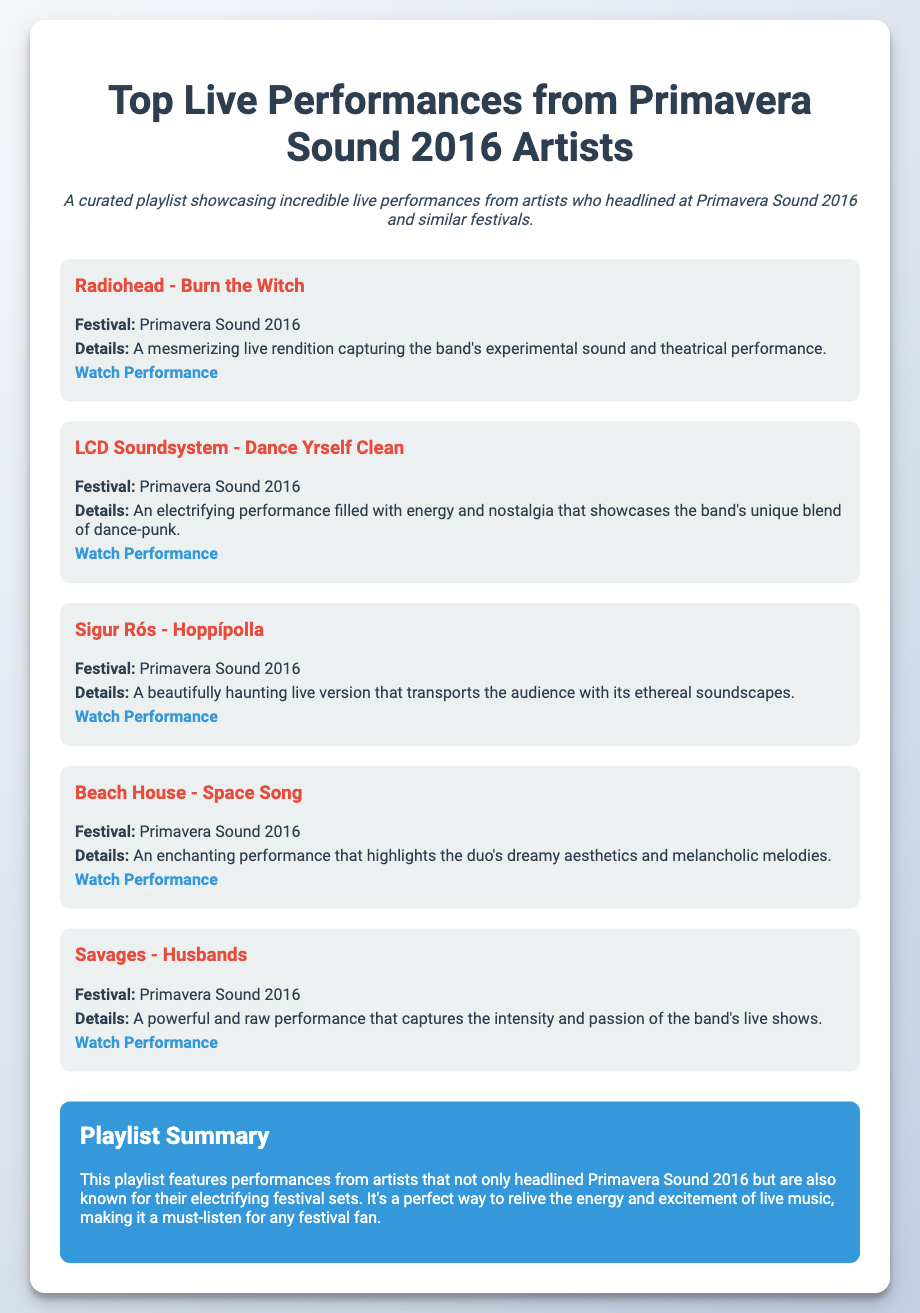What is the title of the playlist? The title of the playlist is stated at the top of the document.
Answer: Top Live Performances from Primavera Sound 2016 Artists Which artist performed "Burn the Witch"? The specific artist is mentioned in the performance details for that track.
Answer: Radiohead How many tracks are included in the playlist? The number of tracks can be determined by counting the individual track sections in the document.
Answer: Five What festival are all these tracks associated with? The festival name is repeated throughout the track descriptions.
Answer: Primavera Sound 2016 Which track features ethereal soundscapes? The track details describe the qualities of the performance.
Answer: Hoppípolla Who performed "Dance Yrself Clean"? The performance detail indicates the name of the artist for that specific track.
Answer: LCD Soundsystem What color is the summary background? The document describes the background color for the summary section.
Answer: Blue Which track is described as powerful and raw? The details explicitly phrase the nature of the performance for that particular track.
Answer: Husbands 